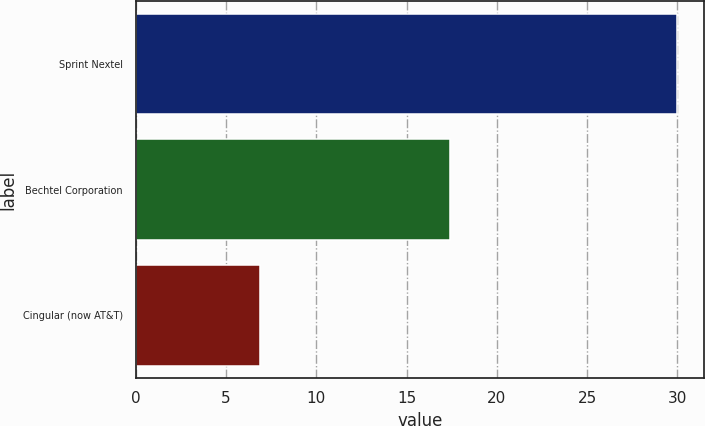Convert chart to OTSL. <chart><loc_0><loc_0><loc_500><loc_500><bar_chart><fcel>Sprint Nextel<fcel>Bechtel Corporation<fcel>Cingular (now AT&T)<nl><fcel>30<fcel>17.4<fcel>6.9<nl></chart> 